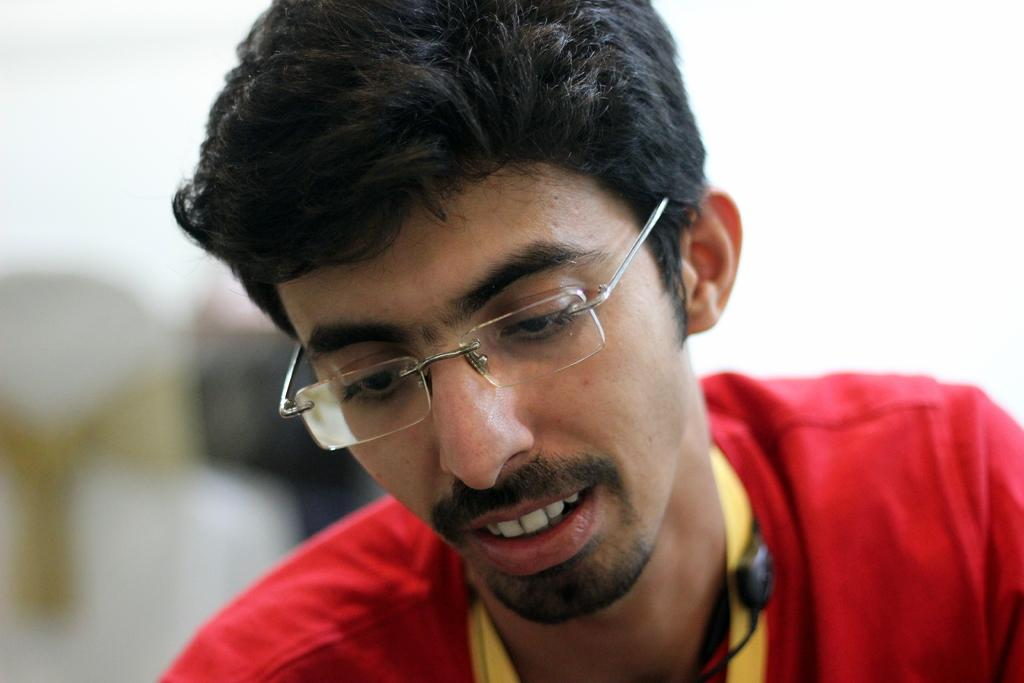What is the main subject of the image? There is a person in the image. Can you describe the background of the image? The background of the image is blurred. What type of guitar is the person playing in the image? There is no guitar present in the image; it only features a person with a blurred background. What flavor of juice is the person holding in the image? There is no juice present in the image; it only features a person with a blurred background. 